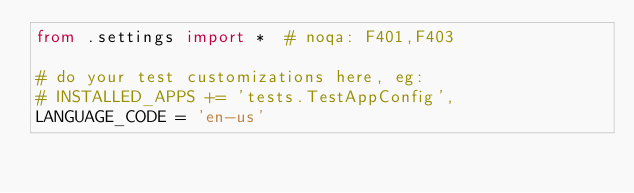<code> <loc_0><loc_0><loc_500><loc_500><_Python_>from .settings import *  # noqa: F401,F403

# do your test customizations here, eg:
# INSTALLED_APPS += 'tests.TestAppConfig',
LANGUAGE_CODE = 'en-us'
</code> 